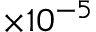<formula> <loc_0><loc_0><loc_500><loc_500>\times 1 0 ^ { - 5 }</formula> 